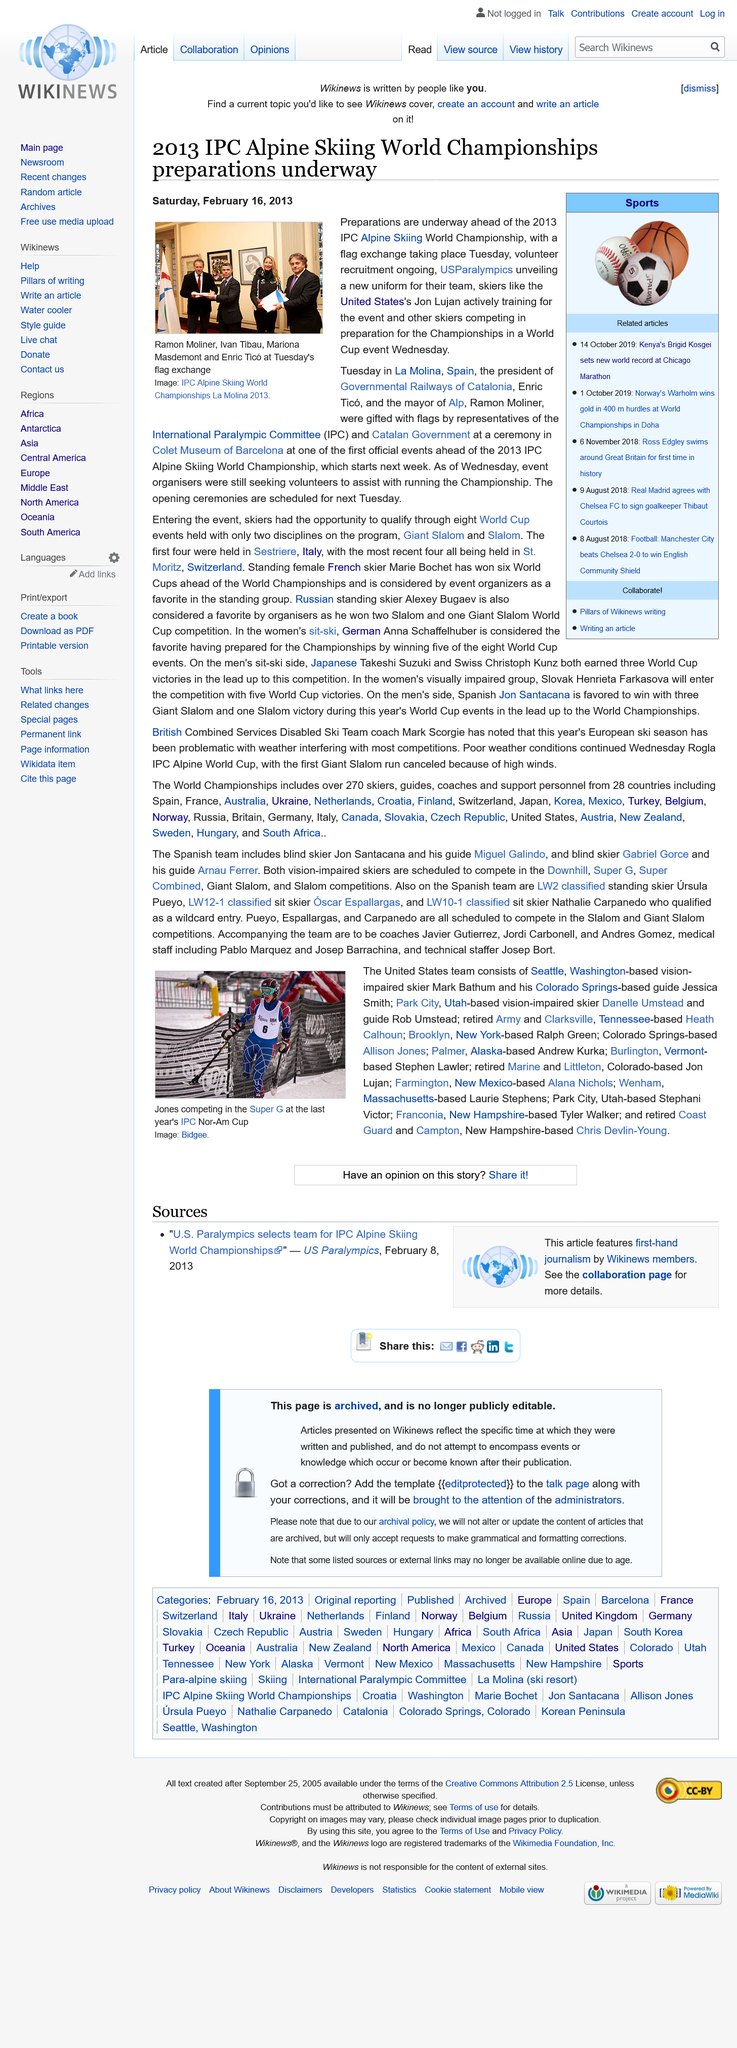Identify some key points in this picture. The opening ceremonies are scheduled to take place on the upcoming Tuesday. The image in the top left was taken at the IPC Alpine Skiing World Championships, which took place at La Molina. On Tuesday, September 18th, 1940, the president of Government Railways of Catalonia was gifted flags at La Molina, Spain. 